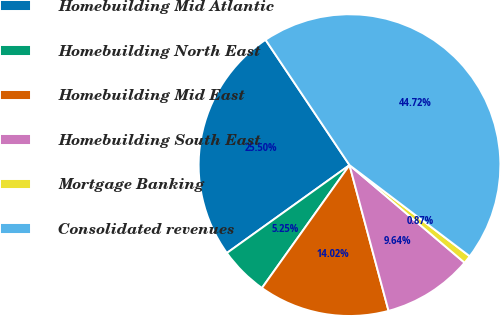<chart> <loc_0><loc_0><loc_500><loc_500><pie_chart><fcel>Homebuilding Mid Atlantic<fcel>Homebuilding North East<fcel>Homebuilding Mid East<fcel>Homebuilding South East<fcel>Mortgage Banking<fcel>Consolidated revenues<nl><fcel>25.5%<fcel>5.25%<fcel>14.02%<fcel>9.64%<fcel>0.87%<fcel>44.72%<nl></chart> 